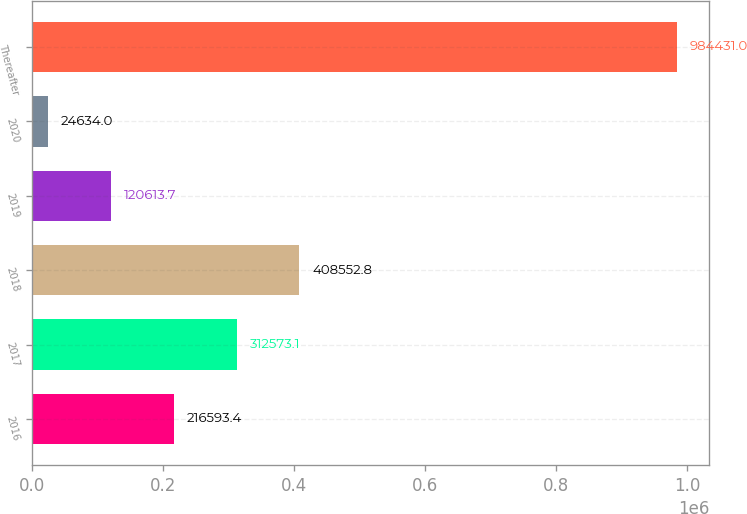Convert chart to OTSL. <chart><loc_0><loc_0><loc_500><loc_500><bar_chart><fcel>2016<fcel>2017<fcel>2018<fcel>2019<fcel>2020<fcel>Thereafter<nl><fcel>216593<fcel>312573<fcel>408553<fcel>120614<fcel>24634<fcel>984431<nl></chart> 